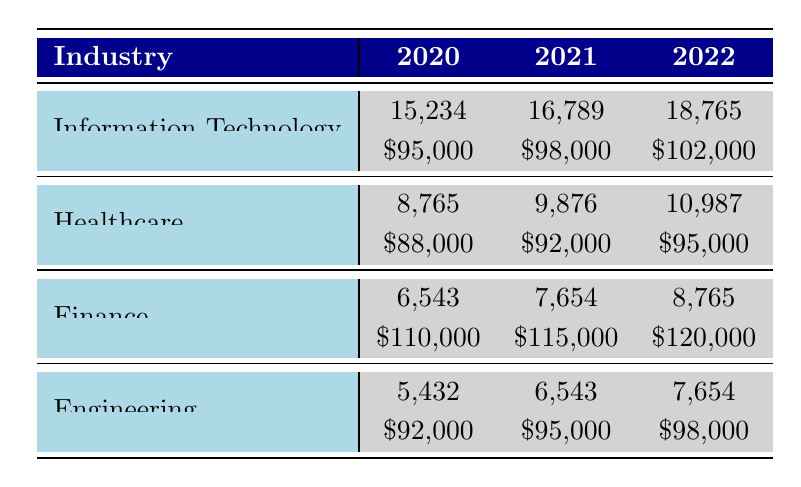What was the number of TN visas issued for the Information Technology industry in 2021? In the table, under the Information Technology row for the year 2021, the value in the Number of Visas column is 16,789.
Answer: 16,789 Which industry had the highest average salary in 2022? The average salaries for each industry in 2022 are: Information Technology at 102,000, Healthcare at 95,000, Finance at 120,000, and Engineering at 98,000. The highest among these is Finance at 120,000.
Answer: Finance How many TN visas were issued in total for the Healthcare industry over the years shown? We need to sum the Number of Visas for Healthcare across the years: 8,765 (2020) + 9,876 (2021) + 10,987 (2022) = 29,628.
Answer: 29,628 Did the number of TN visas for the Engineering industry increase from 2020 to 2022? In 2020, the Engineering industry had 5,432 visas, and in 2022, it had 7,654 visas. Since 7,654 is greater than 5,432, the number of visas did increase.
Answer: Yes What is the average number of TN visas issued per year for the Finance industry? For the Finance industry, the number of TN visas issued is as follows: 6,543 (2020), 7,654 (2021), and 8,765 (2022). The total is 6,543 + 7,654 + 8,765 = 22,962. Average per year is 22,962 / 3 = 7,654.
Answer: 7,654 In which state did the top employer for the Engineering industry in 2021 operate? Looking at the table, the Engineering industry in 2021 lists General Electric as the Top Employer, and it is noted that General Electric is based in Massachusetts.
Answer: Massachusetts Which industry saw the highest increase in the number of TN visas from 2021 to 2022? In 2021, the number of visas for each industry was: Information Technology (16,789), Healthcare (9,876), Finance (7,654), and Engineering (6,543). In 2022, they were: Information Technology (18,765), Healthcare (10,987), Finance (8,765), and Engineering (7,654). The increases are: IT: 1,976, Healthcare: 1,111, Finance: 1,111, Engineering: 1,111. Information Technology had the highest increase of 1,976.
Answer: Information Technology 